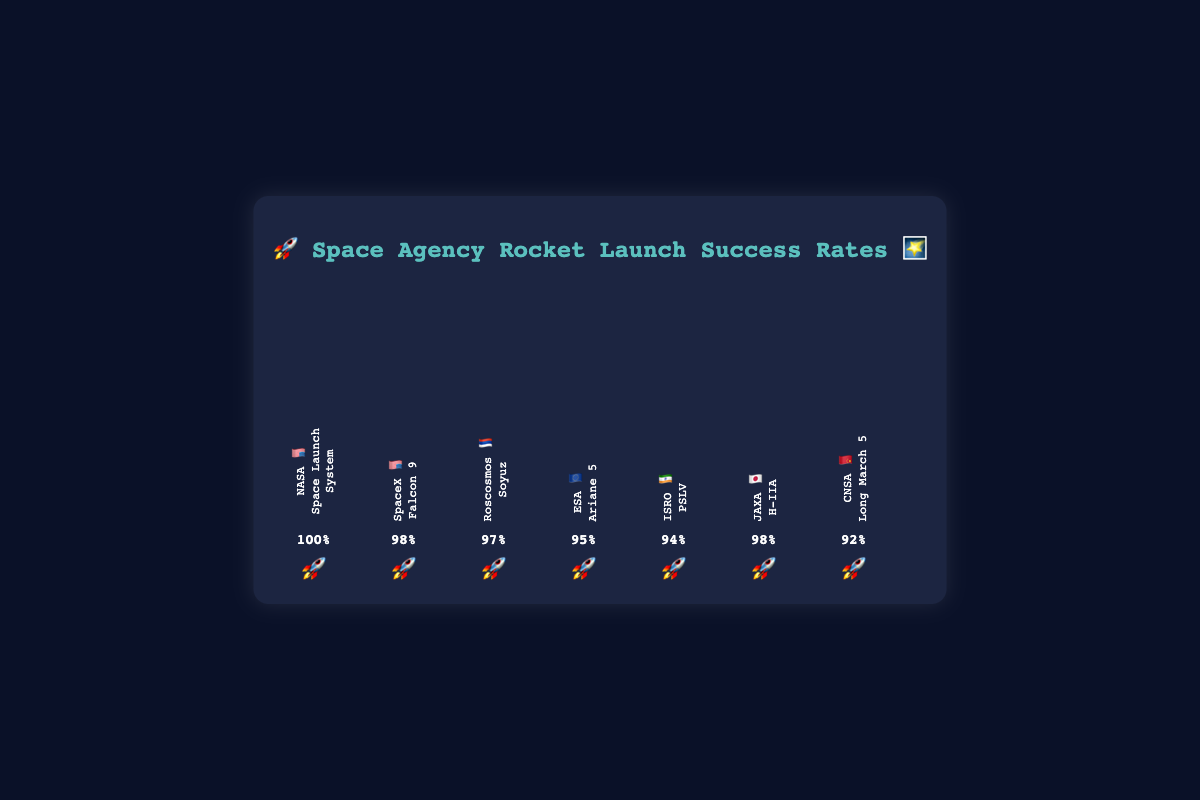What is the success rate of NASA's Space Launch System? The success rate of NASA's Space Launch System is displayed on the bar in the chart.
Answer: 100% Which space agency has the lowest rocket launch success rate? By comparing the heights of the bars and the success rate percentages, CNSA's Long March 5 🚀 has the lowest success rate.
Answer: CNSA 🇨🇳 How does SpaceX's rocket success rate compare to JAXA's? Both SpaceX's Falcon 9 🚀 and JAXA's H-IIA 🚀 have the same success rate, indicated by the same height bars and their success rates of 98%.
Answer: They are equal What is the average rocket success rate of all the agencies? Sum all the success rates (100 + 98 + 97 + 95 + 94 + 98 + 92) and then divide by the number of agencies (7). (100 + 98 + 97 + 95 + 94 + 98 + 92) / 7 = 96.29%
Answer: 96.29% Which agency's rocket has a success rate closest to the overall average? Calculate the average success rate (96.29%) and compare it to each agency's success rate to find the closest. ISRO's PSLV 🚀 success rate of 94% is the closest to the average.
Answer: ISRO 🇮🇳 If we combine the success rates of ESA 🇪🇺 and ISRO 🇮🇳, what would be the sum? Add the success rates of ESA (95%) and ISRO (94%). (95 + 94) = 189%
Answer: 189% Between Roscosmos 🇷🇺 and CNSA 🇨🇳, which has a higher success rate, and by how much? Roscosmos's Soyuz 🚀 has a success rate of 97%, and CNSA's Long March 5 🚀 has a success rate of 92%. (97 - 92) = 5%
Answer: Roscosmos 🇷🇺 by 5% Identify two agencies with the same success rate. By looking at the bars, SpaceX 🇺🇸 and JAXA 🇯🇵 both have a success rate of 98%.
Answer: SpaceX 🇺🇸 and JAXA 🇯🇵 What's the combined success rate of all American agencies mentioned? Add the success rates of NASA and SpaceX. (100 + 98) = 198%
Answer: 198% Which space agency's rocket is designed by JAXA, and what is its success rate? The bar chart indicates that JAXA 🇯🇵 uses the H-IIA 🚀 rocket, which has a success rate of 98%.
Answer: H-IIA 🚀 with 98% 